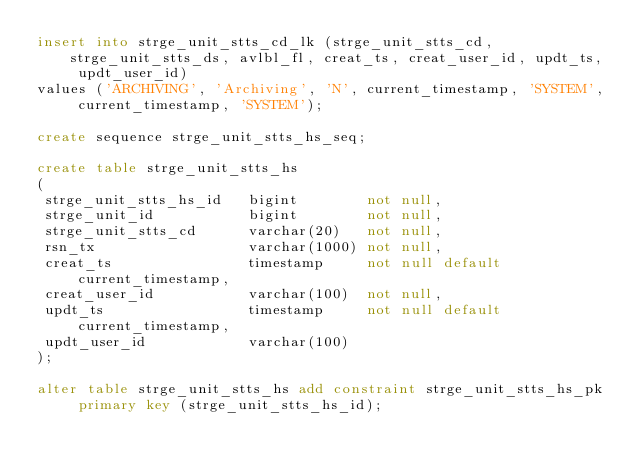Convert code to text. <code><loc_0><loc_0><loc_500><loc_500><_SQL_>insert into strge_unit_stts_cd_lk (strge_unit_stts_cd, strge_unit_stts_ds, avlbl_fl, creat_ts, creat_user_id, updt_ts, updt_user_id)
values ('ARCHIVING', 'Archiving', 'N', current_timestamp, 'SYSTEM', current_timestamp, 'SYSTEM');

create sequence strge_unit_stts_hs_seq;

create table strge_unit_stts_hs
(
 strge_unit_stts_hs_id   bigint        not null,
 strge_unit_id           bigint        not null,
 strge_unit_stts_cd      varchar(20)   not null,
 rsn_tx                  varchar(1000) not null,
 creat_ts                timestamp     not null default current_timestamp,
 creat_user_id           varchar(100)  not null,
 updt_ts                 timestamp     not null default current_timestamp,
 updt_user_id            varchar(100)
);

alter table strge_unit_stts_hs add constraint strge_unit_stts_hs_pk primary key (strge_unit_stts_hs_id);
</code> 